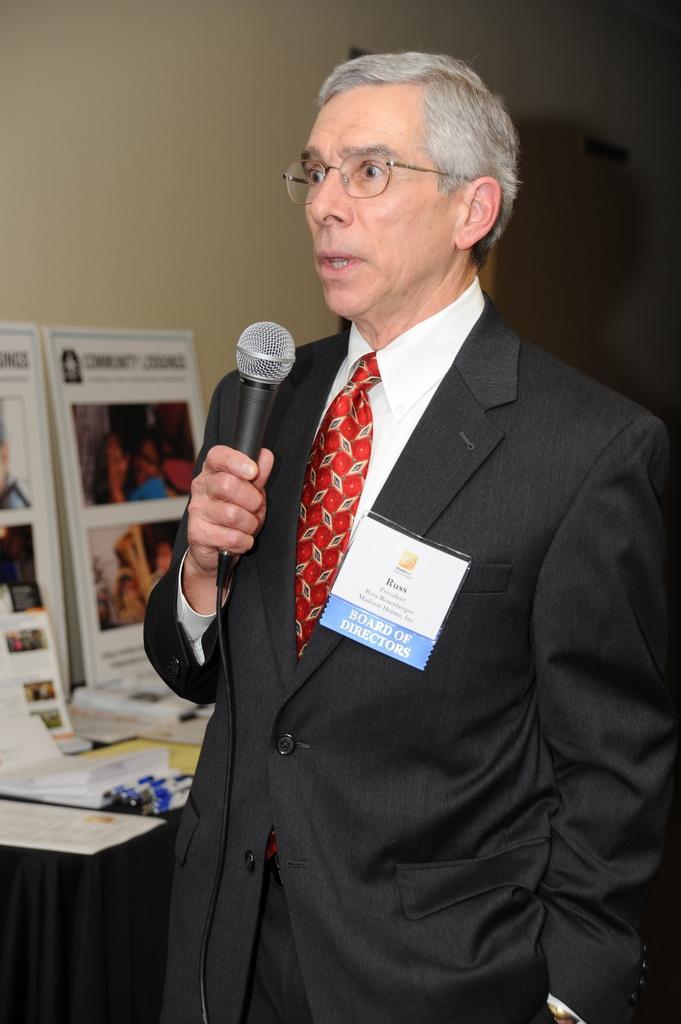Could you give a brief overview of what you see in this image? In this image we can see a person wearing specs and badge. He is holding a mic. In the back there is a wall. Also there is a platform with posters. 